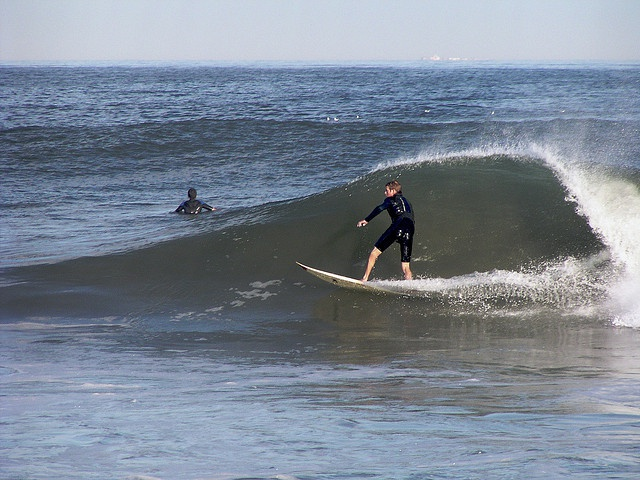Describe the objects in this image and their specific colors. I can see people in darkgray, black, gray, and tan tones, surfboard in darkgray, gray, and ivory tones, people in darkgray, black, gray, and darkblue tones, bird in darkgray and gray tones, and bird in darkgray, gray, and ivory tones in this image. 